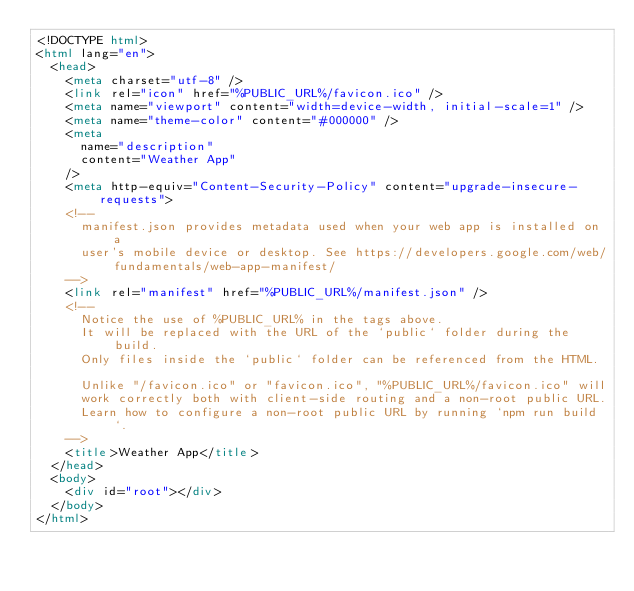Convert code to text. <code><loc_0><loc_0><loc_500><loc_500><_HTML_><!DOCTYPE html>
<html lang="en">
  <head>
    <meta charset="utf-8" />
    <link rel="icon" href="%PUBLIC_URL%/favicon.ico" />
    <meta name="viewport" content="width=device-width, initial-scale=1" />
    <meta name="theme-color" content="#000000" />
    <meta
      name="description"
      content="Weather App"
    />
    <meta http-equiv="Content-Security-Policy" content="upgrade-insecure-requests">
    <!--
      manifest.json provides metadata used when your web app is installed on a
      user's mobile device or desktop. See https://developers.google.com/web/fundamentals/web-app-manifest/
    -->
    <link rel="manifest" href="%PUBLIC_URL%/manifest.json" />
    <!--
      Notice the use of %PUBLIC_URL% in the tags above.
      It will be replaced with the URL of the `public` folder during the build.
      Only files inside the `public` folder can be referenced from the HTML.

      Unlike "/favicon.ico" or "favicon.ico", "%PUBLIC_URL%/favicon.ico" will
      work correctly both with client-side routing and a non-root public URL.
      Learn how to configure a non-root public URL by running `npm run build`.
    -->
    <title>Weather App</title>
  </head>
  <body>
    <div id="root"></div>
  </body>
</html>
</code> 